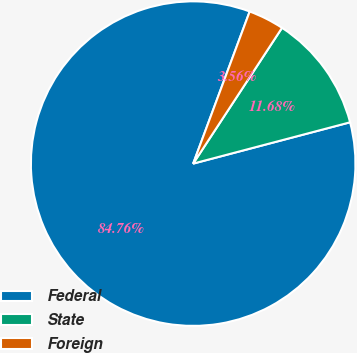Convert chart. <chart><loc_0><loc_0><loc_500><loc_500><pie_chart><fcel>Federal<fcel>State<fcel>Foreign<nl><fcel>84.76%<fcel>11.68%<fcel>3.56%<nl></chart> 